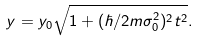<formula> <loc_0><loc_0><loc_500><loc_500>y = y _ { 0 } \sqrt { 1 + ( \hbar { / } 2 m \sigma _ { 0 } ^ { 2 } ) ^ { 2 } t ^ { 2 } } .</formula> 